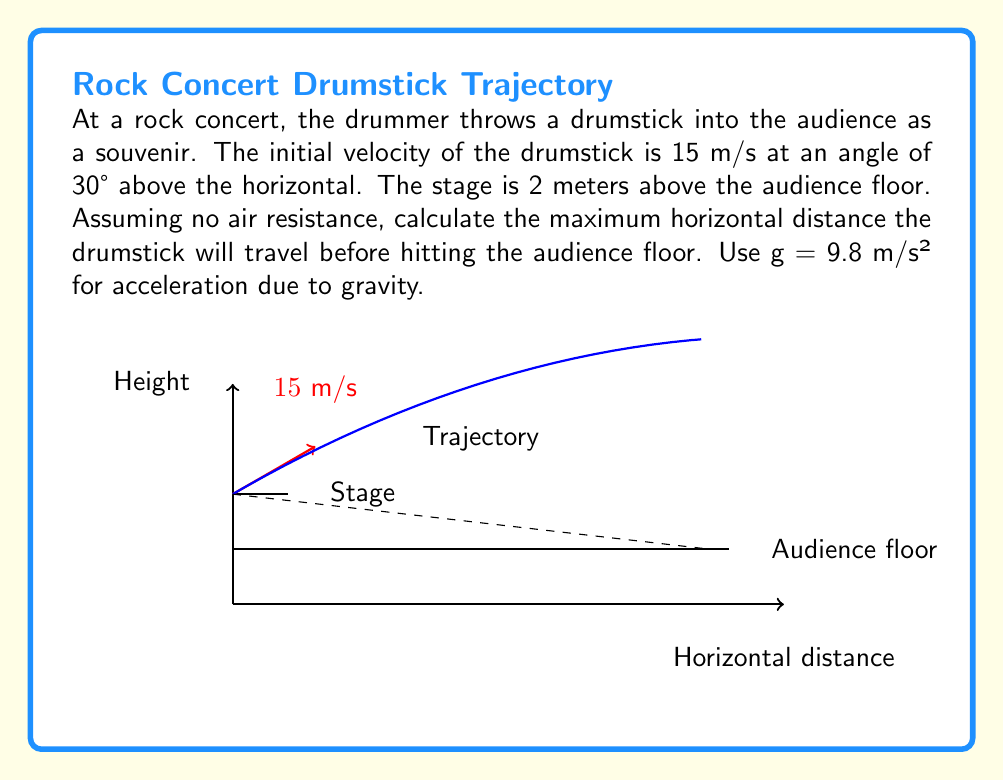Show me your answer to this math problem. Let's solve this problem step by step using the equations of projectile motion:

1) First, let's identify the given information:
   - Initial velocity, $v_0 = 15$ m/s
   - Launch angle, $\theta = 30°$
   - Initial height, $h = 2$ m
   - Acceleration due to gravity, $g = 9.8$ m/s²

2) We need to find the time when the drumstick hits the ground. We can use the vertical motion equation:
   $$y = h + v_0\sin(\theta)t - \frac{1}{2}gt^2$$

3) At the point of impact, $y = 0$. So we can solve:
   $$0 = 2 + 15\sin(30°)t - \frac{1}{2}(9.8)t^2$$

4) Simplify:
   $$0 = 2 + 7.5t - 4.9t^2$$

5) This is a quadratic equation. We can solve it using the quadratic formula:
   $$t = \frac{-b \pm \sqrt{b^2 - 4ac}}{2a}$$
   where $a = -4.9$, $b = 7.5$, and $c = 2$

6) Solving this gives us two solutions. We take the positive one:
   $$t \approx 1.67\text{ s}$$

7) Now that we have the time, we can use the horizontal motion equation to find the distance:
   $$x = v_0\cos(\theta)t$$

8) Plugging in our values:
   $$x = 15\cos(30°)(1.67) \approx 21.68\text{ m}$$

Therefore, the drumstick will travel approximately 21.68 meters horizontally before hitting the audience floor.
Answer: 21.68 m 